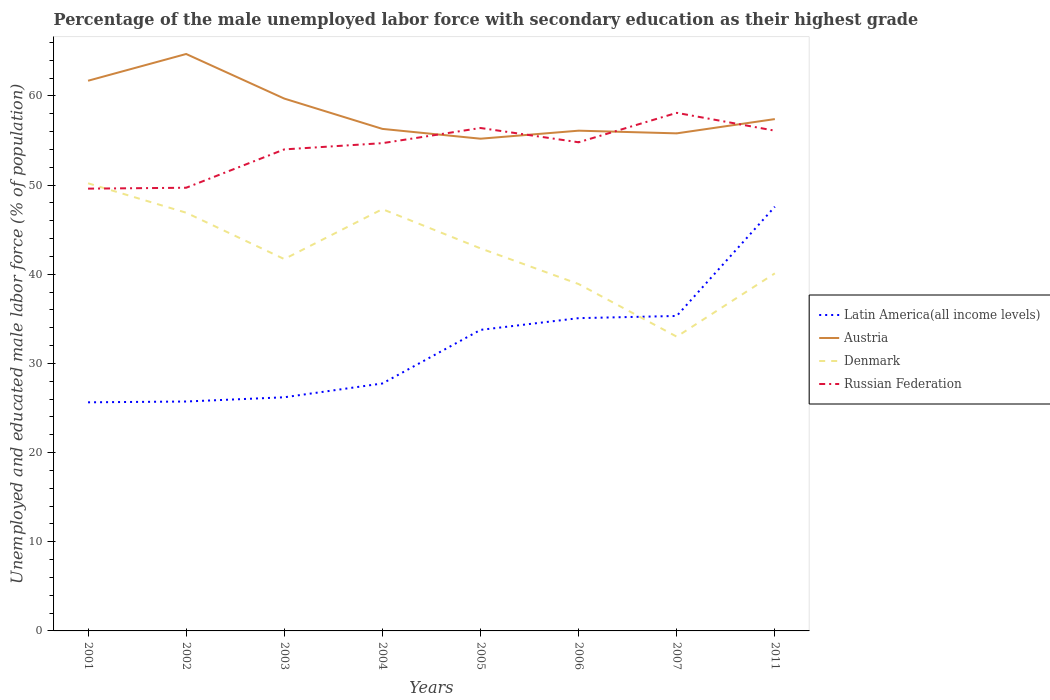How many different coloured lines are there?
Ensure brevity in your answer.  4. Does the line corresponding to Latin America(all income levels) intersect with the line corresponding to Austria?
Make the answer very short. No. What is the total percentage of the unemployed male labor force with secondary education in Denmark in the graph?
Provide a succinct answer. -1.2. What is the difference between the highest and the second highest percentage of the unemployed male labor force with secondary education in Denmark?
Your answer should be compact. 17.2. How many lines are there?
Give a very brief answer. 4. How many years are there in the graph?
Keep it short and to the point. 8. What is the difference between two consecutive major ticks on the Y-axis?
Your answer should be compact. 10. Where does the legend appear in the graph?
Provide a succinct answer. Center right. What is the title of the graph?
Your response must be concise. Percentage of the male unemployed labor force with secondary education as their highest grade. What is the label or title of the X-axis?
Make the answer very short. Years. What is the label or title of the Y-axis?
Give a very brief answer. Unemployed and educated male labor force (% of population). What is the Unemployed and educated male labor force (% of population) in Latin America(all income levels) in 2001?
Offer a terse response. 25.64. What is the Unemployed and educated male labor force (% of population) of Austria in 2001?
Offer a very short reply. 61.7. What is the Unemployed and educated male labor force (% of population) of Denmark in 2001?
Give a very brief answer. 50.2. What is the Unemployed and educated male labor force (% of population) in Russian Federation in 2001?
Keep it short and to the point. 49.6. What is the Unemployed and educated male labor force (% of population) in Latin America(all income levels) in 2002?
Offer a terse response. 25.73. What is the Unemployed and educated male labor force (% of population) in Austria in 2002?
Your answer should be very brief. 64.7. What is the Unemployed and educated male labor force (% of population) in Denmark in 2002?
Give a very brief answer. 46.9. What is the Unemployed and educated male labor force (% of population) in Russian Federation in 2002?
Your answer should be very brief. 49.7. What is the Unemployed and educated male labor force (% of population) of Latin America(all income levels) in 2003?
Make the answer very short. 26.2. What is the Unemployed and educated male labor force (% of population) of Austria in 2003?
Your answer should be very brief. 59.7. What is the Unemployed and educated male labor force (% of population) of Denmark in 2003?
Your answer should be compact. 41.7. What is the Unemployed and educated male labor force (% of population) of Russian Federation in 2003?
Ensure brevity in your answer.  54. What is the Unemployed and educated male labor force (% of population) of Latin America(all income levels) in 2004?
Offer a terse response. 27.75. What is the Unemployed and educated male labor force (% of population) in Austria in 2004?
Make the answer very short. 56.3. What is the Unemployed and educated male labor force (% of population) in Denmark in 2004?
Provide a succinct answer. 47.3. What is the Unemployed and educated male labor force (% of population) in Russian Federation in 2004?
Offer a very short reply. 54.7. What is the Unemployed and educated male labor force (% of population) in Latin America(all income levels) in 2005?
Ensure brevity in your answer.  33.76. What is the Unemployed and educated male labor force (% of population) of Austria in 2005?
Your response must be concise. 55.2. What is the Unemployed and educated male labor force (% of population) of Denmark in 2005?
Offer a very short reply. 42.9. What is the Unemployed and educated male labor force (% of population) of Russian Federation in 2005?
Your response must be concise. 56.4. What is the Unemployed and educated male labor force (% of population) in Latin America(all income levels) in 2006?
Your answer should be compact. 35.08. What is the Unemployed and educated male labor force (% of population) in Austria in 2006?
Your response must be concise. 56.1. What is the Unemployed and educated male labor force (% of population) in Denmark in 2006?
Provide a succinct answer. 38.9. What is the Unemployed and educated male labor force (% of population) in Russian Federation in 2006?
Provide a short and direct response. 54.8. What is the Unemployed and educated male labor force (% of population) in Latin America(all income levels) in 2007?
Make the answer very short. 35.32. What is the Unemployed and educated male labor force (% of population) in Austria in 2007?
Offer a terse response. 55.8. What is the Unemployed and educated male labor force (% of population) in Denmark in 2007?
Ensure brevity in your answer.  33. What is the Unemployed and educated male labor force (% of population) in Russian Federation in 2007?
Provide a succinct answer. 58.1. What is the Unemployed and educated male labor force (% of population) of Latin America(all income levels) in 2011?
Provide a succinct answer. 47.57. What is the Unemployed and educated male labor force (% of population) in Austria in 2011?
Provide a short and direct response. 57.4. What is the Unemployed and educated male labor force (% of population) in Denmark in 2011?
Provide a short and direct response. 40.1. What is the Unemployed and educated male labor force (% of population) of Russian Federation in 2011?
Offer a very short reply. 56.1. Across all years, what is the maximum Unemployed and educated male labor force (% of population) in Latin America(all income levels)?
Ensure brevity in your answer.  47.57. Across all years, what is the maximum Unemployed and educated male labor force (% of population) in Austria?
Keep it short and to the point. 64.7. Across all years, what is the maximum Unemployed and educated male labor force (% of population) of Denmark?
Your answer should be compact. 50.2. Across all years, what is the maximum Unemployed and educated male labor force (% of population) in Russian Federation?
Give a very brief answer. 58.1. Across all years, what is the minimum Unemployed and educated male labor force (% of population) of Latin America(all income levels)?
Provide a short and direct response. 25.64. Across all years, what is the minimum Unemployed and educated male labor force (% of population) of Austria?
Offer a very short reply. 55.2. Across all years, what is the minimum Unemployed and educated male labor force (% of population) in Russian Federation?
Your answer should be very brief. 49.6. What is the total Unemployed and educated male labor force (% of population) of Latin America(all income levels) in the graph?
Your response must be concise. 257.05. What is the total Unemployed and educated male labor force (% of population) in Austria in the graph?
Give a very brief answer. 466.9. What is the total Unemployed and educated male labor force (% of population) of Denmark in the graph?
Ensure brevity in your answer.  341. What is the total Unemployed and educated male labor force (% of population) of Russian Federation in the graph?
Offer a very short reply. 433.4. What is the difference between the Unemployed and educated male labor force (% of population) in Latin America(all income levels) in 2001 and that in 2002?
Ensure brevity in your answer.  -0.09. What is the difference between the Unemployed and educated male labor force (% of population) of Russian Federation in 2001 and that in 2002?
Offer a terse response. -0.1. What is the difference between the Unemployed and educated male labor force (% of population) in Latin America(all income levels) in 2001 and that in 2003?
Keep it short and to the point. -0.57. What is the difference between the Unemployed and educated male labor force (% of population) of Denmark in 2001 and that in 2003?
Your answer should be very brief. 8.5. What is the difference between the Unemployed and educated male labor force (% of population) in Russian Federation in 2001 and that in 2003?
Offer a terse response. -4.4. What is the difference between the Unemployed and educated male labor force (% of population) of Latin America(all income levels) in 2001 and that in 2004?
Your answer should be compact. -2.11. What is the difference between the Unemployed and educated male labor force (% of population) of Austria in 2001 and that in 2004?
Offer a terse response. 5.4. What is the difference between the Unemployed and educated male labor force (% of population) in Russian Federation in 2001 and that in 2004?
Ensure brevity in your answer.  -5.1. What is the difference between the Unemployed and educated male labor force (% of population) in Latin America(all income levels) in 2001 and that in 2005?
Provide a short and direct response. -8.12. What is the difference between the Unemployed and educated male labor force (% of population) in Austria in 2001 and that in 2005?
Your response must be concise. 6.5. What is the difference between the Unemployed and educated male labor force (% of population) of Latin America(all income levels) in 2001 and that in 2006?
Provide a short and direct response. -9.44. What is the difference between the Unemployed and educated male labor force (% of population) of Latin America(all income levels) in 2001 and that in 2007?
Your answer should be very brief. -9.69. What is the difference between the Unemployed and educated male labor force (% of population) of Russian Federation in 2001 and that in 2007?
Keep it short and to the point. -8.5. What is the difference between the Unemployed and educated male labor force (% of population) of Latin America(all income levels) in 2001 and that in 2011?
Keep it short and to the point. -21.94. What is the difference between the Unemployed and educated male labor force (% of population) of Austria in 2001 and that in 2011?
Give a very brief answer. 4.3. What is the difference between the Unemployed and educated male labor force (% of population) of Latin America(all income levels) in 2002 and that in 2003?
Your response must be concise. -0.48. What is the difference between the Unemployed and educated male labor force (% of population) of Denmark in 2002 and that in 2003?
Your response must be concise. 5.2. What is the difference between the Unemployed and educated male labor force (% of population) of Russian Federation in 2002 and that in 2003?
Provide a short and direct response. -4.3. What is the difference between the Unemployed and educated male labor force (% of population) in Latin America(all income levels) in 2002 and that in 2004?
Your response must be concise. -2.02. What is the difference between the Unemployed and educated male labor force (% of population) in Russian Federation in 2002 and that in 2004?
Provide a short and direct response. -5. What is the difference between the Unemployed and educated male labor force (% of population) in Latin America(all income levels) in 2002 and that in 2005?
Give a very brief answer. -8.03. What is the difference between the Unemployed and educated male labor force (% of population) of Russian Federation in 2002 and that in 2005?
Keep it short and to the point. -6.7. What is the difference between the Unemployed and educated male labor force (% of population) of Latin America(all income levels) in 2002 and that in 2006?
Offer a terse response. -9.35. What is the difference between the Unemployed and educated male labor force (% of population) of Latin America(all income levels) in 2002 and that in 2007?
Make the answer very short. -9.59. What is the difference between the Unemployed and educated male labor force (% of population) in Austria in 2002 and that in 2007?
Your response must be concise. 8.9. What is the difference between the Unemployed and educated male labor force (% of population) of Denmark in 2002 and that in 2007?
Offer a very short reply. 13.9. What is the difference between the Unemployed and educated male labor force (% of population) in Latin America(all income levels) in 2002 and that in 2011?
Provide a short and direct response. -21.85. What is the difference between the Unemployed and educated male labor force (% of population) of Austria in 2002 and that in 2011?
Provide a succinct answer. 7.3. What is the difference between the Unemployed and educated male labor force (% of population) in Denmark in 2002 and that in 2011?
Offer a terse response. 6.8. What is the difference between the Unemployed and educated male labor force (% of population) in Latin America(all income levels) in 2003 and that in 2004?
Your answer should be compact. -1.55. What is the difference between the Unemployed and educated male labor force (% of population) in Denmark in 2003 and that in 2004?
Make the answer very short. -5.6. What is the difference between the Unemployed and educated male labor force (% of population) in Russian Federation in 2003 and that in 2004?
Keep it short and to the point. -0.7. What is the difference between the Unemployed and educated male labor force (% of population) of Latin America(all income levels) in 2003 and that in 2005?
Ensure brevity in your answer.  -7.56. What is the difference between the Unemployed and educated male labor force (% of population) in Russian Federation in 2003 and that in 2005?
Make the answer very short. -2.4. What is the difference between the Unemployed and educated male labor force (% of population) in Latin America(all income levels) in 2003 and that in 2006?
Offer a terse response. -8.87. What is the difference between the Unemployed and educated male labor force (% of population) of Russian Federation in 2003 and that in 2006?
Ensure brevity in your answer.  -0.8. What is the difference between the Unemployed and educated male labor force (% of population) of Latin America(all income levels) in 2003 and that in 2007?
Provide a succinct answer. -9.12. What is the difference between the Unemployed and educated male labor force (% of population) of Denmark in 2003 and that in 2007?
Offer a terse response. 8.7. What is the difference between the Unemployed and educated male labor force (% of population) of Latin America(all income levels) in 2003 and that in 2011?
Offer a very short reply. -21.37. What is the difference between the Unemployed and educated male labor force (% of population) in Latin America(all income levels) in 2004 and that in 2005?
Your answer should be very brief. -6.01. What is the difference between the Unemployed and educated male labor force (% of population) of Austria in 2004 and that in 2005?
Give a very brief answer. 1.1. What is the difference between the Unemployed and educated male labor force (% of population) in Denmark in 2004 and that in 2005?
Your answer should be compact. 4.4. What is the difference between the Unemployed and educated male labor force (% of population) of Russian Federation in 2004 and that in 2005?
Provide a succinct answer. -1.7. What is the difference between the Unemployed and educated male labor force (% of population) in Latin America(all income levels) in 2004 and that in 2006?
Your answer should be very brief. -7.33. What is the difference between the Unemployed and educated male labor force (% of population) of Austria in 2004 and that in 2006?
Offer a very short reply. 0.2. What is the difference between the Unemployed and educated male labor force (% of population) of Russian Federation in 2004 and that in 2006?
Your answer should be compact. -0.1. What is the difference between the Unemployed and educated male labor force (% of population) in Latin America(all income levels) in 2004 and that in 2007?
Your response must be concise. -7.57. What is the difference between the Unemployed and educated male labor force (% of population) in Latin America(all income levels) in 2004 and that in 2011?
Keep it short and to the point. -19.82. What is the difference between the Unemployed and educated male labor force (% of population) in Austria in 2004 and that in 2011?
Give a very brief answer. -1.1. What is the difference between the Unemployed and educated male labor force (% of population) of Latin America(all income levels) in 2005 and that in 2006?
Ensure brevity in your answer.  -1.32. What is the difference between the Unemployed and educated male labor force (% of population) in Denmark in 2005 and that in 2006?
Provide a succinct answer. 4. What is the difference between the Unemployed and educated male labor force (% of population) of Latin America(all income levels) in 2005 and that in 2007?
Provide a short and direct response. -1.56. What is the difference between the Unemployed and educated male labor force (% of population) of Austria in 2005 and that in 2007?
Keep it short and to the point. -0.6. What is the difference between the Unemployed and educated male labor force (% of population) in Denmark in 2005 and that in 2007?
Provide a short and direct response. 9.9. What is the difference between the Unemployed and educated male labor force (% of population) in Russian Federation in 2005 and that in 2007?
Provide a succinct answer. -1.7. What is the difference between the Unemployed and educated male labor force (% of population) in Latin America(all income levels) in 2005 and that in 2011?
Provide a short and direct response. -13.81. What is the difference between the Unemployed and educated male labor force (% of population) in Denmark in 2005 and that in 2011?
Offer a very short reply. 2.8. What is the difference between the Unemployed and educated male labor force (% of population) in Russian Federation in 2005 and that in 2011?
Offer a terse response. 0.3. What is the difference between the Unemployed and educated male labor force (% of population) of Latin America(all income levels) in 2006 and that in 2007?
Provide a succinct answer. -0.25. What is the difference between the Unemployed and educated male labor force (% of population) of Austria in 2006 and that in 2007?
Your answer should be compact. 0.3. What is the difference between the Unemployed and educated male labor force (% of population) of Denmark in 2006 and that in 2007?
Your response must be concise. 5.9. What is the difference between the Unemployed and educated male labor force (% of population) of Russian Federation in 2006 and that in 2007?
Offer a very short reply. -3.3. What is the difference between the Unemployed and educated male labor force (% of population) in Latin America(all income levels) in 2006 and that in 2011?
Your answer should be compact. -12.5. What is the difference between the Unemployed and educated male labor force (% of population) of Austria in 2006 and that in 2011?
Provide a short and direct response. -1.3. What is the difference between the Unemployed and educated male labor force (% of population) in Russian Federation in 2006 and that in 2011?
Offer a terse response. -1.3. What is the difference between the Unemployed and educated male labor force (% of population) in Latin America(all income levels) in 2007 and that in 2011?
Ensure brevity in your answer.  -12.25. What is the difference between the Unemployed and educated male labor force (% of population) of Austria in 2007 and that in 2011?
Keep it short and to the point. -1.6. What is the difference between the Unemployed and educated male labor force (% of population) in Denmark in 2007 and that in 2011?
Keep it short and to the point. -7.1. What is the difference between the Unemployed and educated male labor force (% of population) of Russian Federation in 2007 and that in 2011?
Your answer should be very brief. 2. What is the difference between the Unemployed and educated male labor force (% of population) in Latin America(all income levels) in 2001 and the Unemployed and educated male labor force (% of population) in Austria in 2002?
Offer a very short reply. -39.06. What is the difference between the Unemployed and educated male labor force (% of population) in Latin America(all income levels) in 2001 and the Unemployed and educated male labor force (% of population) in Denmark in 2002?
Ensure brevity in your answer.  -21.26. What is the difference between the Unemployed and educated male labor force (% of population) of Latin America(all income levels) in 2001 and the Unemployed and educated male labor force (% of population) of Russian Federation in 2002?
Ensure brevity in your answer.  -24.06. What is the difference between the Unemployed and educated male labor force (% of population) in Austria in 2001 and the Unemployed and educated male labor force (% of population) in Denmark in 2002?
Make the answer very short. 14.8. What is the difference between the Unemployed and educated male labor force (% of population) in Latin America(all income levels) in 2001 and the Unemployed and educated male labor force (% of population) in Austria in 2003?
Your answer should be compact. -34.06. What is the difference between the Unemployed and educated male labor force (% of population) in Latin America(all income levels) in 2001 and the Unemployed and educated male labor force (% of population) in Denmark in 2003?
Offer a terse response. -16.06. What is the difference between the Unemployed and educated male labor force (% of population) of Latin America(all income levels) in 2001 and the Unemployed and educated male labor force (% of population) of Russian Federation in 2003?
Your response must be concise. -28.36. What is the difference between the Unemployed and educated male labor force (% of population) in Austria in 2001 and the Unemployed and educated male labor force (% of population) in Denmark in 2003?
Ensure brevity in your answer.  20. What is the difference between the Unemployed and educated male labor force (% of population) in Latin America(all income levels) in 2001 and the Unemployed and educated male labor force (% of population) in Austria in 2004?
Offer a very short reply. -30.66. What is the difference between the Unemployed and educated male labor force (% of population) of Latin America(all income levels) in 2001 and the Unemployed and educated male labor force (% of population) of Denmark in 2004?
Keep it short and to the point. -21.66. What is the difference between the Unemployed and educated male labor force (% of population) in Latin America(all income levels) in 2001 and the Unemployed and educated male labor force (% of population) in Russian Federation in 2004?
Make the answer very short. -29.06. What is the difference between the Unemployed and educated male labor force (% of population) of Austria in 2001 and the Unemployed and educated male labor force (% of population) of Russian Federation in 2004?
Provide a succinct answer. 7. What is the difference between the Unemployed and educated male labor force (% of population) in Denmark in 2001 and the Unemployed and educated male labor force (% of population) in Russian Federation in 2004?
Your answer should be compact. -4.5. What is the difference between the Unemployed and educated male labor force (% of population) in Latin America(all income levels) in 2001 and the Unemployed and educated male labor force (% of population) in Austria in 2005?
Offer a very short reply. -29.56. What is the difference between the Unemployed and educated male labor force (% of population) of Latin America(all income levels) in 2001 and the Unemployed and educated male labor force (% of population) of Denmark in 2005?
Make the answer very short. -17.26. What is the difference between the Unemployed and educated male labor force (% of population) of Latin America(all income levels) in 2001 and the Unemployed and educated male labor force (% of population) of Russian Federation in 2005?
Give a very brief answer. -30.76. What is the difference between the Unemployed and educated male labor force (% of population) of Austria in 2001 and the Unemployed and educated male labor force (% of population) of Denmark in 2005?
Your answer should be very brief. 18.8. What is the difference between the Unemployed and educated male labor force (% of population) in Denmark in 2001 and the Unemployed and educated male labor force (% of population) in Russian Federation in 2005?
Give a very brief answer. -6.2. What is the difference between the Unemployed and educated male labor force (% of population) in Latin America(all income levels) in 2001 and the Unemployed and educated male labor force (% of population) in Austria in 2006?
Your answer should be compact. -30.46. What is the difference between the Unemployed and educated male labor force (% of population) in Latin America(all income levels) in 2001 and the Unemployed and educated male labor force (% of population) in Denmark in 2006?
Offer a terse response. -13.26. What is the difference between the Unemployed and educated male labor force (% of population) of Latin America(all income levels) in 2001 and the Unemployed and educated male labor force (% of population) of Russian Federation in 2006?
Your answer should be very brief. -29.16. What is the difference between the Unemployed and educated male labor force (% of population) in Austria in 2001 and the Unemployed and educated male labor force (% of population) in Denmark in 2006?
Give a very brief answer. 22.8. What is the difference between the Unemployed and educated male labor force (% of population) of Austria in 2001 and the Unemployed and educated male labor force (% of population) of Russian Federation in 2006?
Offer a very short reply. 6.9. What is the difference between the Unemployed and educated male labor force (% of population) in Latin America(all income levels) in 2001 and the Unemployed and educated male labor force (% of population) in Austria in 2007?
Ensure brevity in your answer.  -30.16. What is the difference between the Unemployed and educated male labor force (% of population) in Latin America(all income levels) in 2001 and the Unemployed and educated male labor force (% of population) in Denmark in 2007?
Provide a short and direct response. -7.36. What is the difference between the Unemployed and educated male labor force (% of population) of Latin America(all income levels) in 2001 and the Unemployed and educated male labor force (% of population) of Russian Federation in 2007?
Your answer should be very brief. -32.46. What is the difference between the Unemployed and educated male labor force (% of population) in Austria in 2001 and the Unemployed and educated male labor force (% of population) in Denmark in 2007?
Your response must be concise. 28.7. What is the difference between the Unemployed and educated male labor force (% of population) in Austria in 2001 and the Unemployed and educated male labor force (% of population) in Russian Federation in 2007?
Give a very brief answer. 3.6. What is the difference between the Unemployed and educated male labor force (% of population) of Latin America(all income levels) in 2001 and the Unemployed and educated male labor force (% of population) of Austria in 2011?
Offer a terse response. -31.76. What is the difference between the Unemployed and educated male labor force (% of population) of Latin America(all income levels) in 2001 and the Unemployed and educated male labor force (% of population) of Denmark in 2011?
Your answer should be compact. -14.46. What is the difference between the Unemployed and educated male labor force (% of population) of Latin America(all income levels) in 2001 and the Unemployed and educated male labor force (% of population) of Russian Federation in 2011?
Provide a short and direct response. -30.46. What is the difference between the Unemployed and educated male labor force (% of population) in Austria in 2001 and the Unemployed and educated male labor force (% of population) in Denmark in 2011?
Provide a succinct answer. 21.6. What is the difference between the Unemployed and educated male labor force (% of population) in Latin America(all income levels) in 2002 and the Unemployed and educated male labor force (% of population) in Austria in 2003?
Keep it short and to the point. -33.97. What is the difference between the Unemployed and educated male labor force (% of population) in Latin America(all income levels) in 2002 and the Unemployed and educated male labor force (% of population) in Denmark in 2003?
Provide a succinct answer. -15.97. What is the difference between the Unemployed and educated male labor force (% of population) of Latin America(all income levels) in 2002 and the Unemployed and educated male labor force (% of population) of Russian Federation in 2003?
Provide a succinct answer. -28.27. What is the difference between the Unemployed and educated male labor force (% of population) of Austria in 2002 and the Unemployed and educated male labor force (% of population) of Denmark in 2003?
Your response must be concise. 23. What is the difference between the Unemployed and educated male labor force (% of population) of Austria in 2002 and the Unemployed and educated male labor force (% of population) of Russian Federation in 2003?
Your response must be concise. 10.7. What is the difference between the Unemployed and educated male labor force (% of population) of Denmark in 2002 and the Unemployed and educated male labor force (% of population) of Russian Federation in 2003?
Your response must be concise. -7.1. What is the difference between the Unemployed and educated male labor force (% of population) of Latin America(all income levels) in 2002 and the Unemployed and educated male labor force (% of population) of Austria in 2004?
Your answer should be very brief. -30.57. What is the difference between the Unemployed and educated male labor force (% of population) of Latin America(all income levels) in 2002 and the Unemployed and educated male labor force (% of population) of Denmark in 2004?
Keep it short and to the point. -21.57. What is the difference between the Unemployed and educated male labor force (% of population) of Latin America(all income levels) in 2002 and the Unemployed and educated male labor force (% of population) of Russian Federation in 2004?
Provide a succinct answer. -28.97. What is the difference between the Unemployed and educated male labor force (% of population) in Austria in 2002 and the Unemployed and educated male labor force (% of population) in Russian Federation in 2004?
Your answer should be compact. 10. What is the difference between the Unemployed and educated male labor force (% of population) in Denmark in 2002 and the Unemployed and educated male labor force (% of population) in Russian Federation in 2004?
Ensure brevity in your answer.  -7.8. What is the difference between the Unemployed and educated male labor force (% of population) in Latin America(all income levels) in 2002 and the Unemployed and educated male labor force (% of population) in Austria in 2005?
Provide a short and direct response. -29.47. What is the difference between the Unemployed and educated male labor force (% of population) of Latin America(all income levels) in 2002 and the Unemployed and educated male labor force (% of population) of Denmark in 2005?
Provide a succinct answer. -17.17. What is the difference between the Unemployed and educated male labor force (% of population) in Latin America(all income levels) in 2002 and the Unemployed and educated male labor force (% of population) in Russian Federation in 2005?
Offer a terse response. -30.67. What is the difference between the Unemployed and educated male labor force (% of population) of Austria in 2002 and the Unemployed and educated male labor force (% of population) of Denmark in 2005?
Offer a terse response. 21.8. What is the difference between the Unemployed and educated male labor force (% of population) of Austria in 2002 and the Unemployed and educated male labor force (% of population) of Russian Federation in 2005?
Your answer should be very brief. 8.3. What is the difference between the Unemployed and educated male labor force (% of population) in Latin America(all income levels) in 2002 and the Unemployed and educated male labor force (% of population) in Austria in 2006?
Your answer should be compact. -30.37. What is the difference between the Unemployed and educated male labor force (% of population) of Latin America(all income levels) in 2002 and the Unemployed and educated male labor force (% of population) of Denmark in 2006?
Your response must be concise. -13.17. What is the difference between the Unemployed and educated male labor force (% of population) in Latin America(all income levels) in 2002 and the Unemployed and educated male labor force (% of population) in Russian Federation in 2006?
Provide a short and direct response. -29.07. What is the difference between the Unemployed and educated male labor force (% of population) in Austria in 2002 and the Unemployed and educated male labor force (% of population) in Denmark in 2006?
Provide a succinct answer. 25.8. What is the difference between the Unemployed and educated male labor force (% of population) of Denmark in 2002 and the Unemployed and educated male labor force (% of population) of Russian Federation in 2006?
Ensure brevity in your answer.  -7.9. What is the difference between the Unemployed and educated male labor force (% of population) of Latin America(all income levels) in 2002 and the Unemployed and educated male labor force (% of population) of Austria in 2007?
Provide a short and direct response. -30.07. What is the difference between the Unemployed and educated male labor force (% of population) of Latin America(all income levels) in 2002 and the Unemployed and educated male labor force (% of population) of Denmark in 2007?
Give a very brief answer. -7.27. What is the difference between the Unemployed and educated male labor force (% of population) in Latin America(all income levels) in 2002 and the Unemployed and educated male labor force (% of population) in Russian Federation in 2007?
Offer a very short reply. -32.37. What is the difference between the Unemployed and educated male labor force (% of population) of Austria in 2002 and the Unemployed and educated male labor force (% of population) of Denmark in 2007?
Offer a very short reply. 31.7. What is the difference between the Unemployed and educated male labor force (% of population) in Denmark in 2002 and the Unemployed and educated male labor force (% of population) in Russian Federation in 2007?
Your answer should be compact. -11.2. What is the difference between the Unemployed and educated male labor force (% of population) of Latin America(all income levels) in 2002 and the Unemployed and educated male labor force (% of population) of Austria in 2011?
Make the answer very short. -31.67. What is the difference between the Unemployed and educated male labor force (% of population) of Latin America(all income levels) in 2002 and the Unemployed and educated male labor force (% of population) of Denmark in 2011?
Your response must be concise. -14.37. What is the difference between the Unemployed and educated male labor force (% of population) in Latin America(all income levels) in 2002 and the Unemployed and educated male labor force (% of population) in Russian Federation in 2011?
Provide a short and direct response. -30.37. What is the difference between the Unemployed and educated male labor force (% of population) in Austria in 2002 and the Unemployed and educated male labor force (% of population) in Denmark in 2011?
Provide a short and direct response. 24.6. What is the difference between the Unemployed and educated male labor force (% of population) of Austria in 2002 and the Unemployed and educated male labor force (% of population) of Russian Federation in 2011?
Provide a short and direct response. 8.6. What is the difference between the Unemployed and educated male labor force (% of population) in Denmark in 2002 and the Unemployed and educated male labor force (% of population) in Russian Federation in 2011?
Keep it short and to the point. -9.2. What is the difference between the Unemployed and educated male labor force (% of population) in Latin America(all income levels) in 2003 and the Unemployed and educated male labor force (% of population) in Austria in 2004?
Provide a succinct answer. -30.1. What is the difference between the Unemployed and educated male labor force (% of population) in Latin America(all income levels) in 2003 and the Unemployed and educated male labor force (% of population) in Denmark in 2004?
Provide a short and direct response. -21.1. What is the difference between the Unemployed and educated male labor force (% of population) of Latin America(all income levels) in 2003 and the Unemployed and educated male labor force (% of population) of Russian Federation in 2004?
Your answer should be compact. -28.5. What is the difference between the Unemployed and educated male labor force (% of population) in Austria in 2003 and the Unemployed and educated male labor force (% of population) in Russian Federation in 2004?
Your response must be concise. 5. What is the difference between the Unemployed and educated male labor force (% of population) in Denmark in 2003 and the Unemployed and educated male labor force (% of population) in Russian Federation in 2004?
Ensure brevity in your answer.  -13. What is the difference between the Unemployed and educated male labor force (% of population) in Latin America(all income levels) in 2003 and the Unemployed and educated male labor force (% of population) in Austria in 2005?
Offer a terse response. -29. What is the difference between the Unemployed and educated male labor force (% of population) of Latin America(all income levels) in 2003 and the Unemployed and educated male labor force (% of population) of Denmark in 2005?
Provide a succinct answer. -16.7. What is the difference between the Unemployed and educated male labor force (% of population) in Latin America(all income levels) in 2003 and the Unemployed and educated male labor force (% of population) in Russian Federation in 2005?
Ensure brevity in your answer.  -30.2. What is the difference between the Unemployed and educated male labor force (% of population) of Austria in 2003 and the Unemployed and educated male labor force (% of population) of Denmark in 2005?
Keep it short and to the point. 16.8. What is the difference between the Unemployed and educated male labor force (% of population) in Denmark in 2003 and the Unemployed and educated male labor force (% of population) in Russian Federation in 2005?
Your response must be concise. -14.7. What is the difference between the Unemployed and educated male labor force (% of population) in Latin America(all income levels) in 2003 and the Unemployed and educated male labor force (% of population) in Austria in 2006?
Make the answer very short. -29.9. What is the difference between the Unemployed and educated male labor force (% of population) in Latin America(all income levels) in 2003 and the Unemployed and educated male labor force (% of population) in Denmark in 2006?
Give a very brief answer. -12.7. What is the difference between the Unemployed and educated male labor force (% of population) of Latin America(all income levels) in 2003 and the Unemployed and educated male labor force (% of population) of Russian Federation in 2006?
Offer a very short reply. -28.6. What is the difference between the Unemployed and educated male labor force (% of population) in Austria in 2003 and the Unemployed and educated male labor force (% of population) in Denmark in 2006?
Provide a succinct answer. 20.8. What is the difference between the Unemployed and educated male labor force (% of population) in Denmark in 2003 and the Unemployed and educated male labor force (% of population) in Russian Federation in 2006?
Your response must be concise. -13.1. What is the difference between the Unemployed and educated male labor force (% of population) of Latin America(all income levels) in 2003 and the Unemployed and educated male labor force (% of population) of Austria in 2007?
Give a very brief answer. -29.6. What is the difference between the Unemployed and educated male labor force (% of population) of Latin America(all income levels) in 2003 and the Unemployed and educated male labor force (% of population) of Denmark in 2007?
Give a very brief answer. -6.8. What is the difference between the Unemployed and educated male labor force (% of population) in Latin America(all income levels) in 2003 and the Unemployed and educated male labor force (% of population) in Russian Federation in 2007?
Offer a very short reply. -31.9. What is the difference between the Unemployed and educated male labor force (% of population) of Austria in 2003 and the Unemployed and educated male labor force (% of population) of Denmark in 2007?
Offer a very short reply. 26.7. What is the difference between the Unemployed and educated male labor force (% of population) in Denmark in 2003 and the Unemployed and educated male labor force (% of population) in Russian Federation in 2007?
Your answer should be very brief. -16.4. What is the difference between the Unemployed and educated male labor force (% of population) in Latin America(all income levels) in 2003 and the Unemployed and educated male labor force (% of population) in Austria in 2011?
Provide a short and direct response. -31.2. What is the difference between the Unemployed and educated male labor force (% of population) of Latin America(all income levels) in 2003 and the Unemployed and educated male labor force (% of population) of Denmark in 2011?
Your answer should be very brief. -13.9. What is the difference between the Unemployed and educated male labor force (% of population) of Latin America(all income levels) in 2003 and the Unemployed and educated male labor force (% of population) of Russian Federation in 2011?
Your response must be concise. -29.9. What is the difference between the Unemployed and educated male labor force (% of population) of Austria in 2003 and the Unemployed and educated male labor force (% of population) of Denmark in 2011?
Your response must be concise. 19.6. What is the difference between the Unemployed and educated male labor force (% of population) of Austria in 2003 and the Unemployed and educated male labor force (% of population) of Russian Federation in 2011?
Provide a succinct answer. 3.6. What is the difference between the Unemployed and educated male labor force (% of population) of Denmark in 2003 and the Unemployed and educated male labor force (% of population) of Russian Federation in 2011?
Your answer should be very brief. -14.4. What is the difference between the Unemployed and educated male labor force (% of population) in Latin America(all income levels) in 2004 and the Unemployed and educated male labor force (% of population) in Austria in 2005?
Make the answer very short. -27.45. What is the difference between the Unemployed and educated male labor force (% of population) of Latin America(all income levels) in 2004 and the Unemployed and educated male labor force (% of population) of Denmark in 2005?
Keep it short and to the point. -15.15. What is the difference between the Unemployed and educated male labor force (% of population) in Latin America(all income levels) in 2004 and the Unemployed and educated male labor force (% of population) in Russian Federation in 2005?
Provide a short and direct response. -28.65. What is the difference between the Unemployed and educated male labor force (% of population) in Austria in 2004 and the Unemployed and educated male labor force (% of population) in Russian Federation in 2005?
Ensure brevity in your answer.  -0.1. What is the difference between the Unemployed and educated male labor force (% of population) in Latin America(all income levels) in 2004 and the Unemployed and educated male labor force (% of population) in Austria in 2006?
Offer a very short reply. -28.35. What is the difference between the Unemployed and educated male labor force (% of population) in Latin America(all income levels) in 2004 and the Unemployed and educated male labor force (% of population) in Denmark in 2006?
Ensure brevity in your answer.  -11.15. What is the difference between the Unemployed and educated male labor force (% of population) of Latin America(all income levels) in 2004 and the Unemployed and educated male labor force (% of population) of Russian Federation in 2006?
Your answer should be compact. -27.05. What is the difference between the Unemployed and educated male labor force (% of population) of Austria in 2004 and the Unemployed and educated male labor force (% of population) of Denmark in 2006?
Give a very brief answer. 17.4. What is the difference between the Unemployed and educated male labor force (% of population) in Austria in 2004 and the Unemployed and educated male labor force (% of population) in Russian Federation in 2006?
Make the answer very short. 1.5. What is the difference between the Unemployed and educated male labor force (% of population) of Latin America(all income levels) in 2004 and the Unemployed and educated male labor force (% of population) of Austria in 2007?
Your answer should be compact. -28.05. What is the difference between the Unemployed and educated male labor force (% of population) in Latin America(all income levels) in 2004 and the Unemployed and educated male labor force (% of population) in Denmark in 2007?
Your answer should be very brief. -5.25. What is the difference between the Unemployed and educated male labor force (% of population) of Latin America(all income levels) in 2004 and the Unemployed and educated male labor force (% of population) of Russian Federation in 2007?
Your response must be concise. -30.35. What is the difference between the Unemployed and educated male labor force (% of population) of Austria in 2004 and the Unemployed and educated male labor force (% of population) of Denmark in 2007?
Your answer should be very brief. 23.3. What is the difference between the Unemployed and educated male labor force (% of population) of Austria in 2004 and the Unemployed and educated male labor force (% of population) of Russian Federation in 2007?
Provide a succinct answer. -1.8. What is the difference between the Unemployed and educated male labor force (% of population) in Latin America(all income levels) in 2004 and the Unemployed and educated male labor force (% of population) in Austria in 2011?
Make the answer very short. -29.65. What is the difference between the Unemployed and educated male labor force (% of population) of Latin America(all income levels) in 2004 and the Unemployed and educated male labor force (% of population) of Denmark in 2011?
Your response must be concise. -12.35. What is the difference between the Unemployed and educated male labor force (% of population) in Latin America(all income levels) in 2004 and the Unemployed and educated male labor force (% of population) in Russian Federation in 2011?
Provide a succinct answer. -28.35. What is the difference between the Unemployed and educated male labor force (% of population) in Denmark in 2004 and the Unemployed and educated male labor force (% of population) in Russian Federation in 2011?
Your response must be concise. -8.8. What is the difference between the Unemployed and educated male labor force (% of population) of Latin America(all income levels) in 2005 and the Unemployed and educated male labor force (% of population) of Austria in 2006?
Your answer should be very brief. -22.34. What is the difference between the Unemployed and educated male labor force (% of population) in Latin America(all income levels) in 2005 and the Unemployed and educated male labor force (% of population) in Denmark in 2006?
Ensure brevity in your answer.  -5.14. What is the difference between the Unemployed and educated male labor force (% of population) of Latin America(all income levels) in 2005 and the Unemployed and educated male labor force (% of population) of Russian Federation in 2006?
Offer a terse response. -21.04. What is the difference between the Unemployed and educated male labor force (% of population) in Austria in 2005 and the Unemployed and educated male labor force (% of population) in Russian Federation in 2006?
Give a very brief answer. 0.4. What is the difference between the Unemployed and educated male labor force (% of population) in Latin America(all income levels) in 2005 and the Unemployed and educated male labor force (% of population) in Austria in 2007?
Your answer should be very brief. -22.04. What is the difference between the Unemployed and educated male labor force (% of population) in Latin America(all income levels) in 2005 and the Unemployed and educated male labor force (% of population) in Denmark in 2007?
Keep it short and to the point. 0.76. What is the difference between the Unemployed and educated male labor force (% of population) in Latin America(all income levels) in 2005 and the Unemployed and educated male labor force (% of population) in Russian Federation in 2007?
Ensure brevity in your answer.  -24.34. What is the difference between the Unemployed and educated male labor force (% of population) in Austria in 2005 and the Unemployed and educated male labor force (% of population) in Russian Federation in 2007?
Your response must be concise. -2.9. What is the difference between the Unemployed and educated male labor force (% of population) in Denmark in 2005 and the Unemployed and educated male labor force (% of population) in Russian Federation in 2007?
Your answer should be very brief. -15.2. What is the difference between the Unemployed and educated male labor force (% of population) in Latin America(all income levels) in 2005 and the Unemployed and educated male labor force (% of population) in Austria in 2011?
Your answer should be very brief. -23.64. What is the difference between the Unemployed and educated male labor force (% of population) of Latin America(all income levels) in 2005 and the Unemployed and educated male labor force (% of population) of Denmark in 2011?
Ensure brevity in your answer.  -6.34. What is the difference between the Unemployed and educated male labor force (% of population) in Latin America(all income levels) in 2005 and the Unemployed and educated male labor force (% of population) in Russian Federation in 2011?
Offer a very short reply. -22.34. What is the difference between the Unemployed and educated male labor force (% of population) in Austria in 2005 and the Unemployed and educated male labor force (% of population) in Russian Federation in 2011?
Keep it short and to the point. -0.9. What is the difference between the Unemployed and educated male labor force (% of population) of Latin America(all income levels) in 2006 and the Unemployed and educated male labor force (% of population) of Austria in 2007?
Keep it short and to the point. -20.72. What is the difference between the Unemployed and educated male labor force (% of population) in Latin America(all income levels) in 2006 and the Unemployed and educated male labor force (% of population) in Denmark in 2007?
Offer a very short reply. 2.08. What is the difference between the Unemployed and educated male labor force (% of population) of Latin America(all income levels) in 2006 and the Unemployed and educated male labor force (% of population) of Russian Federation in 2007?
Offer a very short reply. -23.02. What is the difference between the Unemployed and educated male labor force (% of population) in Austria in 2006 and the Unemployed and educated male labor force (% of population) in Denmark in 2007?
Ensure brevity in your answer.  23.1. What is the difference between the Unemployed and educated male labor force (% of population) of Austria in 2006 and the Unemployed and educated male labor force (% of population) of Russian Federation in 2007?
Offer a very short reply. -2. What is the difference between the Unemployed and educated male labor force (% of population) in Denmark in 2006 and the Unemployed and educated male labor force (% of population) in Russian Federation in 2007?
Provide a succinct answer. -19.2. What is the difference between the Unemployed and educated male labor force (% of population) of Latin America(all income levels) in 2006 and the Unemployed and educated male labor force (% of population) of Austria in 2011?
Keep it short and to the point. -22.32. What is the difference between the Unemployed and educated male labor force (% of population) in Latin America(all income levels) in 2006 and the Unemployed and educated male labor force (% of population) in Denmark in 2011?
Your answer should be very brief. -5.02. What is the difference between the Unemployed and educated male labor force (% of population) of Latin America(all income levels) in 2006 and the Unemployed and educated male labor force (% of population) of Russian Federation in 2011?
Keep it short and to the point. -21.02. What is the difference between the Unemployed and educated male labor force (% of population) in Austria in 2006 and the Unemployed and educated male labor force (% of population) in Russian Federation in 2011?
Keep it short and to the point. 0. What is the difference between the Unemployed and educated male labor force (% of population) in Denmark in 2006 and the Unemployed and educated male labor force (% of population) in Russian Federation in 2011?
Make the answer very short. -17.2. What is the difference between the Unemployed and educated male labor force (% of population) in Latin America(all income levels) in 2007 and the Unemployed and educated male labor force (% of population) in Austria in 2011?
Make the answer very short. -22.08. What is the difference between the Unemployed and educated male labor force (% of population) of Latin America(all income levels) in 2007 and the Unemployed and educated male labor force (% of population) of Denmark in 2011?
Provide a succinct answer. -4.78. What is the difference between the Unemployed and educated male labor force (% of population) in Latin America(all income levels) in 2007 and the Unemployed and educated male labor force (% of population) in Russian Federation in 2011?
Your response must be concise. -20.78. What is the difference between the Unemployed and educated male labor force (% of population) in Austria in 2007 and the Unemployed and educated male labor force (% of population) in Denmark in 2011?
Ensure brevity in your answer.  15.7. What is the difference between the Unemployed and educated male labor force (% of population) of Denmark in 2007 and the Unemployed and educated male labor force (% of population) of Russian Federation in 2011?
Your answer should be very brief. -23.1. What is the average Unemployed and educated male labor force (% of population) of Latin America(all income levels) per year?
Provide a succinct answer. 32.13. What is the average Unemployed and educated male labor force (% of population) in Austria per year?
Make the answer very short. 58.36. What is the average Unemployed and educated male labor force (% of population) in Denmark per year?
Ensure brevity in your answer.  42.62. What is the average Unemployed and educated male labor force (% of population) in Russian Federation per year?
Make the answer very short. 54.17. In the year 2001, what is the difference between the Unemployed and educated male labor force (% of population) of Latin America(all income levels) and Unemployed and educated male labor force (% of population) of Austria?
Provide a succinct answer. -36.06. In the year 2001, what is the difference between the Unemployed and educated male labor force (% of population) of Latin America(all income levels) and Unemployed and educated male labor force (% of population) of Denmark?
Your response must be concise. -24.56. In the year 2001, what is the difference between the Unemployed and educated male labor force (% of population) of Latin America(all income levels) and Unemployed and educated male labor force (% of population) of Russian Federation?
Offer a terse response. -23.96. In the year 2001, what is the difference between the Unemployed and educated male labor force (% of population) in Austria and Unemployed and educated male labor force (% of population) in Denmark?
Offer a very short reply. 11.5. In the year 2001, what is the difference between the Unemployed and educated male labor force (% of population) in Austria and Unemployed and educated male labor force (% of population) in Russian Federation?
Make the answer very short. 12.1. In the year 2001, what is the difference between the Unemployed and educated male labor force (% of population) of Denmark and Unemployed and educated male labor force (% of population) of Russian Federation?
Keep it short and to the point. 0.6. In the year 2002, what is the difference between the Unemployed and educated male labor force (% of population) in Latin America(all income levels) and Unemployed and educated male labor force (% of population) in Austria?
Give a very brief answer. -38.97. In the year 2002, what is the difference between the Unemployed and educated male labor force (% of population) of Latin America(all income levels) and Unemployed and educated male labor force (% of population) of Denmark?
Your response must be concise. -21.17. In the year 2002, what is the difference between the Unemployed and educated male labor force (% of population) in Latin America(all income levels) and Unemployed and educated male labor force (% of population) in Russian Federation?
Make the answer very short. -23.97. In the year 2003, what is the difference between the Unemployed and educated male labor force (% of population) in Latin America(all income levels) and Unemployed and educated male labor force (% of population) in Austria?
Give a very brief answer. -33.5. In the year 2003, what is the difference between the Unemployed and educated male labor force (% of population) in Latin America(all income levels) and Unemployed and educated male labor force (% of population) in Denmark?
Your answer should be compact. -15.5. In the year 2003, what is the difference between the Unemployed and educated male labor force (% of population) in Latin America(all income levels) and Unemployed and educated male labor force (% of population) in Russian Federation?
Your answer should be compact. -27.8. In the year 2003, what is the difference between the Unemployed and educated male labor force (% of population) in Austria and Unemployed and educated male labor force (% of population) in Denmark?
Keep it short and to the point. 18. In the year 2003, what is the difference between the Unemployed and educated male labor force (% of population) in Austria and Unemployed and educated male labor force (% of population) in Russian Federation?
Ensure brevity in your answer.  5.7. In the year 2004, what is the difference between the Unemployed and educated male labor force (% of population) in Latin America(all income levels) and Unemployed and educated male labor force (% of population) in Austria?
Offer a terse response. -28.55. In the year 2004, what is the difference between the Unemployed and educated male labor force (% of population) in Latin America(all income levels) and Unemployed and educated male labor force (% of population) in Denmark?
Your response must be concise. -19.55. In the year 2004, what is the difference between the Unemployed and educated male labor force (% of population) in Latin America(all income levels) and Unemployed and educated male labor force (% of population) in Russian Federation?
Provide a succinct answer. -26.95. In the year 2004, what is the difference between the Unemployed and educated male labor force (% of population) of Austria and Unemployed and educated male labor force (% of population) of Denmark?
Make the answer very short. 9. In the year 2005, what is the difference between the Unemployed and educated male labor force (% of population) in Latin America(all income levels) and Unemployed and educated male labor force (% of population) in Austria?
Make the answer very short. -21.44. In the year 2005, what is the difference between the Unemployed and educated male labor force (% of population) of Latin America(all income levels) and Unemployed and educated male labor force (% of population) of Denmark?
Make the answer very short. -9.14. In the year 2005, what is the difference between the Unemployed and educated male labor force (% of population) in Latin America(all income levels) and Unemployed and educated male labor force (% of population) in Russian Federation?
Your answer should be very brief. -22.64. In the year 2005, what is the difference between the Unemployed and educated male labor force (% of population) in Austria and Unemployed and educated male labor force (% of population) in Denmark?
Your response must be concise. 12.3. In the year 2006, what is the difference between the Unemployed and educated male labor force (% of population) in Latin America(all income levels) and Unemployed and educated male labor force (% of population) in Austria?
Ensure brevity in your answer.  -21.02. In the year 2006, what is the difference between the Unemployed and educated male labor force (% of population) of Latin America(all income levels) and Unemployed and educated male labor force (% of population) of Denmark?
Give a very brief answer. -3.82. In the year 2006, what is the difference between the Unemployed and educated male labor force (% of population) of Latin America(all income levels) and Unemployed and educated male labor force (% of population) of Russian Federation?
Ensure brevity in your answer.  -19.72. In the year 2006, what is the difference between the Unemployed and educated male labor force (% of population) in Austria and Unemployed and educated male labor force (% of population) in Denmark?
Make the answer very short. 17.2. In the year 2006, what is the difference between the Unemployed and educated male labor force (% of population) of Austria and Unemployed and educated male labor force (% of population) of Russian Federation?
Make the answer very short. 1.3. In the year 2006, what is the difference between the Unemployed and educated male labor force (% of population) of Denmark and Unemployed and educated male labor force (% of population) of Russian Federation?
Make the answer very short. -15.9. In the year 2007, what is the difference between the Unemployed and educated male labor force (% of population) of Latin America(all income levels) and Unemployed and educated male labor force (% of population) of Austria?
Your answer should be compact. -20.48. In the year 2007, what is the difference between the Unemployed and educated male labor force (% of population) in Latin America(all income levels) and Unemployed and educated male labor force (% of population) in Denmark?
Your answer should be very brief. 2.32. In the year 2007, what is the difference between the Unemployed and educated male labor force (% of population) in Latin America(all income levels) and Unemployed and educated male labor force (% of population) in Russian Federation?
Provide a succinct answer. -22.78. In the year 2007, what is the difference between the Unemployed and educated male labor force (% of population) in Austria and Unemployed and educated male labor force (% of population) in Denmark?
Your response must be concise. 22.8. In the year 2007, what is the difference between the Unemployed and educated male labor force (% of population) of Austria and Unemployed and educated male labor force (% of population) of Russian Federation?
Make the answer very short. -2.3. In the year 2007, what is the difference between the Unemployed and educated male labor force (% of population) in Denmark and Unemployed and educated male labor force (% of population) in Russian Federation?
Give a very brief answer. -25.1. In the year 2011, what is the difference between the Unemployed and educated male labor force (% of population) in Latin America(all income levels) and Unemployed and educated male labor force (% of population) in Austria?
Give a very brief answer. -9.83. In the year 2011, what is the difference between the Unemployed and educated male labor force (% of population) in Latin America(all income levels) and Unemployed and educated male labor force (% of population) in Denmark?
Offer a very short reply. 7.47. In the year 2011, what is the difference between the Unemployed and educated male labor force (% of population) of Latin America(all income levels) and Unemployed and educated male labor force (% of population) of Russian Federation?
Offer a very short reply. -8.53. In the year 2011, what is the difference between the Unemployed and educated male labor force (% of population) of Denmark and Unemployed and educated male labor force (% of population) of Russian Federation?
Provide a succinct answer. -16. What is the ratio of the Unemployed and educated male labor force (% of population) in Latin America(all income levels) in 2001 to that in 2002?
Keep it short and to the point. 1. What is the ratio of the Unemployed and educated male labor force (% of population) of Austria in 2001 to that in 2002?
Give a very brief answer. 0.95. What is the ratio of the Unemployed and educated male labor force (% of population) in Denmark in 2001 to that in 2002?
Your answer should be very brief. 1.07. What is the ratio of the Unemployed and educated male labor force (% of population) of Latin America(all income levels) in 2001 to that in 2003?
Your answer should be compact. 0.98. What is the ratio of the Unemployed and educated male labor force (% of population) of Austria in 2001 to that in 2003?
Keep it short and to the point. 1.03. What is the ratio of the Unemployed and educated male labor force (% of population) of Denmark in 2001 to that in 2003?
Your answer should be very brief. 1.2. What is the ratio of the Unemployed and educated male labor force (% of population) of Russian Federation in 2001 to that in 2003?
Offer a very short reply. 0.92. What is the ratio of the Unemployed and educated male labor force (% of population) of Latin America(all income levels) in 2001 to that in 2004?
Your response must be concise. 0.92. What is the ratio of the Unemployed and educated male labor force (% of population) of Austria in 2001 to that in 2004?
Your answer should be very brief. 1.1. What is the ratio of the Unemployed and educated male labor force (% of population) of Denmark in 2001 to that in 2004?
Your response must be concise. 1.06. What is the ratio of the Unemployed and educated male labor force (% of population) of Russian Federation in 2001 to that in 2004?
Your answer should be very brief. 0.91. What is the ratio of the Unemployed and educated male labor force (% of population) in Latin America(all income levels) in 2001 to that in 2005?
Provide a succinct answer. 0.76. What is the ratio of the Unemployed and educated male labor force (% of population) of Austria in 2001 to that in 2005?
Make the answer very short. 1.12. What is the ratio of the Unemployed and educated male labor force (% of population) of Denmark in 2001 to that in 2005?
Provide a succinct answer. 1.17. What is the ratio of the Unemployed and educated male labor force (% of population) in Russian Federation in 2001 to that in 2005?
Keep it short and to the point. 0.88. What is the ratio of the Unemployed and educated male labor force (% of population) of Latin America(all income levels) in 2001 to that in 2006?
Your answer should be compact. 0.73. What is the ratio of the Unemployed and educated male labor force (% of population) in Austria in 2001 to that in 2006?
Give a very brief answer. 1.1. What is the ratio of the Unemployed and educated male labor force (% of population) in Denmark in 2001 to that in 2006?
Offer a terse response. 1.29. What is the ratio of the Unemployed and educated male labor force (% of population) of Russian Federation in 2001 to that in 2006?
Keep it short and to the point. 0.91. What is the ratio of the Unemployed and educated male labor force (% of population) in Latin America(all income levels) in 2001 to that in 2007?
Offer a very short reply. 0.73. What is the ratio of the Unemployed and educated male labor force (% of population) in Austria in 2001 to that in 2007?
Keep it short and to the point. 1.11. What is the ratio of the Unemployed and educated male labor force (% of population) of Denmark in 2001 to that in 2007?
Make the answer very short. 1.52. What is the ratio of the Unemployed and educated male labor force (% of population) in Russian Federation in 2001 to that in 2007?
Your response must be concise. 0.85. What is the ratio of the Unemployed and educated male labor force (% of population) in Latin America(all income levels) in 2001 to that in 2011?
Your answer should be very brief. 0.54. What is the ratio of the Unemployed and educated male labor force (% of population) of Austria in 2001 to that in 2011?
Your answer should be compact. 1.07. What is the ratio of the Unemployed and educated male labor force (% of population) of Denmark in 2001 to that in 2011?
Provide a succinct answer. 1.25. What is the ratio of the Unemployed and educated male labor force (% of population) of Russian Federation in 2001 to that in 2011?
Your answer should be compact. 0.88. What is the ratio of the Unemployed and educated male labor force (% of population) in Latin America(all income levels) in 2002 to that in 2003?
Your answer should be compact. 0.98. What is the ratio of the Unemployed and educated male labor force (% of population) in Austria in 2002 to that in 2003?
Keep it short and to the point. 1.08. What is the ratio of the Unemployed and educated male labor force (% of population) in Denmark in 2002 to that in 2003?
Provide a succinct answer. 1.12. What is the ratio of the Unemployed and educated male labor force (% of population) of Russian Federation in 2002 to that in 2003?
Make the answer very short. 0.92. What is the ratio of the Unemployed and educated male labor force (% of population) of Latin America(all income levels) in 2002 to that in 2004?
Offer a terse response. 0.93. What is the ratio of the Unemployed and educated male labor force (% of population) in Austria in 2002 to that in 2004?
Your answer should be compact. 1.15. What is the ratio of the Unemployed and educated male labor force (% of population) of Russian Federation in 2002 to that in 2004?
Make the answer very short. 0.91. What is the ratio of the Unemployed and educated male labor force (% of population) in Latin America(all income levels) in 2002 to that in 2005?
Offer a terse response. 0.76. What is the ratio of the Unemployed and educated male labor force (% of population) of Austria in 2002 to that in 2005?
Give a very brief answer. 1.17. What is the ratio of the Unemployed and educated male labor force (% of population) in Denmark in 2002 to that in 2005?
Keep it short and to the point. 1.09. What is the ratio of the Unemployed and educated male labor force (% of population) of Russian Federation in 2002 to that in 2005?
Your response must be concise. 0.88. What is the ratio of the Unemployed and educated male labor force (% of population) of Latin America(all income levels) in 2002 to that in 2006?
Keep it short and to the point. 0.73. What is the ratio of the Unemployed and educated male labor force (% of population) of Austria in 2002 to that in 2006?
Provide a succinct answer. 1.15. What is the ratio of the Unemployed and educated male labor force (% of population) of Denmark in 2002 to that in 2006?
Provide a succinct answer. 1.21. What is the ratio of the Unemployed and educated male labor force (% of population) of Russian Federation in 2002 to that in 2006?
Ensure brevity in your answer.  0.91. What is the ratio of the Unemployed and educated male labor force (% of population) of Latin America(all income levels) in 2002 to that in 2007?
Make the answer very short. 0.73. What is the ratio of the Unemployed and educated male labor force (% of population) in Austria in 2002 to that in 2007?
Ensure brevity in your answer.  1.16. What is the ratio of the Unemployed and educated male labor force (% of population) of Denmark in 2002 to that in 2007?
Keep it short and to the point. 1.42. What is the ratio of the Unemployed and educated male labor force (% of population) of Russian Federation in 2002 to that in 2007?
Offer a very short reply. 0.86. What is the ratio of the Unemployed and educated male labor force (% of population) in Latin America(all income levels) in 2002 to that in 2011?
Provide a short and direct response. 0.54. What is the ratio of the Unemployed and educated male labor force (% of population) in Austria in 2002 to that in 2011?
Your answer should be very brief. 1.13. What is the ratio of the Unemployed and educated male labor force (% of population) of Denmark in 2002 to that in 2011?
Make the answer very short. 1.17. What is the ratio of the Unemployed and educated male labor force (% of population) in Russian Federation in 2002 to that in 2011?
Offer a terse response. 0.89. What is the ratio of the Unemployed and educated male labor force (% of population) in Latin America(all income levels) in 2003 to that in 2004?
Keep it short and to the point. 0.94. What is the ratio of the Unemployed and educated male labor force (% of population) of Austria in 2003 to that in 2004?
Keep it short and to the point. 1.06. What is the ratio of the Unemployed and educated male labor force (% of population) in Denmark in 2003 to that in 2004?
Keep it short and to the point. 0.88. What is the ratio of the Unemployed and educated male labor force (% of population) in Russian Federation in 2003 to that in 2004?
Your answer should be very brief. 0.99. What is the ratio of the Unemployed and educated male labor force (% of population) of Latin America(all income levels) in 2003 to that in 2005?
Offer a very short reply. 0.78. What is the ratio of the Unemployed and educated male labor force (% of population) of Austria in 2003 to that in 2005?
Make the answer very short. 1.08. What is the ratio of the Unemployed and educated male labor force (% of population) in Denmark in 2003 to that in 2005?
Make the answer very short. 0.97. What is the ratio of the Unemployed and educated male labor force (% of population) in Russian Federation in 2003 to that in 2005?
Offer a terse response. 0.96. What is the ratio of the Unemployed and educated male labor force (% of population) of Latin America(all income levels) in 2003 to that in 2006?
Ensure brevity in your answer.  0.75. What is the ratio of the Unemployed and educated male labor force (% of population) in Austria in 2003 to that in 2006?
Your answer should be compact. 1.06. What is the ratio of the Unemployed and educated male labor force (% of population) in Denmark in 2003 to that in 2006?
Give a very brief answer. 1.07. What is the ratio of the Unemployed and educated male labor force (% of population) in Russian Federation in 2003 to that in 2006?
Ensure brevity in your answer.  0.99. What is the ratio of the Unemployed and educated male labor force (% of population) of Latin America(all income levels) in 2003 to that in 2007?
Keep it short and to the point. 0.74. What is the ratio of the Unemployed and educated male labor force (% of population) of Austria in 2003 to that in 2007?
Ensure brevity in your answer.  1.07. What is the ratio of the Unemployed and educated male labor force (% of population) of Denmark in 2003 to that in 2007?
Provide a succinct answer. 1.26. What is the ratio of the Unemployed and educated male labor force (% of population) of Russian Federation in 2003 to that in 2007?
Offer a terse response. 0.93. What is the ratio of the Unemployed and educated male labor force (% of population) of Latin America(all income levels) in 2003 to that in 2011?
Your answer should be compact. 0.55. What is the ratio of the Unemployed and educated male labor force (% of population) of Austria in 2003 to that in 2011?
Offer a very short reply. 1.04. What is the ratio of the Unemployed and educated male labor force (% of population) of Denmark in 2003 to that in 2011?
Provide a succinct answer. 1.04. What is the ratio of the Unemployed and educated male labor force (% of population) in Russian Federation in 2003 to that in 2011?
Offer a terse response. 0.96. What is the ratio of the Unemployed and educated male labor force (% of population) in Latin America(all income levels) in 2004 to that in 2005?
Keep it short and to the point. 0.82. What is the ratio of the Unemployed and educated male labor force (% of population) of Austria in 2004 to that in 2005?
Offer a terse response. 1.02. What is the ratio of the Unemployed and educated male labor force (% of population) in Denmark in 2004 to that in 2005?
Provide a short and direct response. 1.1. What is the ratio of the Unemployed and educated male labor force (% of population) in Russian Federation in 2004 to that in 2005?
Make the answer very short. 0.97. What is the ratio of the Unemployed and educated male labor force (% of population) of Latin America(all income levels) in 2004 to that in 2006?
Give a very brief answer. 0.79. What is the ratio of the Unemployed and educated male labor force (% of population) of Denmark in 2004 to that in 2006?
Your answer should be very brief. 1.22. What is the ratio of the Unemployed and educated male labor force (% of population) of Russian Federation in 2004 to that in 2006?
Your response must be concise. 1. What is the ratio of the Unemployed and educated male labor force (% of population) in Latin America(all income levels) in 2004 to that in 2007?
Your answer should be very brief. 0.79. What is the ratio of the Unemployed and educated male labor force (% of population) in Denmark in 2004 to that in 2007?
Your answer should be very brief. 1.43. What is the ratio of the Unemployed and educated male labor force (% of population) in Russian Federation in 2004 to that in 2007?
Offer a terse response. 0.94. What is the ratio of the Unemployed and educated male labor force (% of population) in Latin America(all income levels) in 2004 to that in 2011?
Offer a terse response. 0.58. What is the ratio of the Unemployed and educated male labor force (% of population) in Austria in 2004 to that in 2011?
Offer a very short reply. 0.98. What is the ratio of the Unemployed and educated male labor force (% of population) of Denmark in 2004 to that in 2011?
Keep it short and to the point. 1.18. What is the ratio of the Unemployed and educated male labor force (% of population) of Russian Federation in 2004 to that in 2011?
Provide a short and direct response. 0.97. What is the ratio of the Unemployed and educated male labor force (% of population) of Latin America(all income levels) in 2005 to that in 2006?
Provide a succinct answer. 0.96. What is the ratio of the Unemployed and educated male labor force (% of population) in Austria in 2005 to that in 2006?
Make the answer very short. 0.98. What is the ratio of the Unemployed and educated male labor force (% of population) in Denmark in 2005 to that in 2006?
Provide a short and direct response. 1.1. What is the ratio of the Unemployed and educated male labor force (% of population) of Russian Federation in 2005 to that in 2006?
Your response must be concise. 1.03. What is the ratio of the Unemployed and educated male labor force (% of population) of Latin America(all income levels) in 2005 to that in 2007?
Your response must be concise. 0.96. What is the ratio of the Unemployed and educated male labor force (% of population) in Austria in 2005 to that in 2007?
Your response must be concise. 0.99. What is the ratio of the Unemployed and educated male labor force (% of population) in Russian Federation in 2005 to that in 2007?
Keep it short and to the point. 0.97. What is the ratio of the Unemployed and educated male labor force (% of population) in Latin America(all income levels) in 2005 to that in 2011?
Keep it short and to the point. 0.71. What is the ratio of the Unemployed and educated male labor force (% of population) of Austria in 2005 to that in 2011?
Make the answer very short. 0.96. What is the ratio of the Unemployed and educated male labor force (% of population) in Denmark in 2005 to that in 2011?
Offer a terse response. 1.07. What is the ratio of the Unemployed and educated male labor force (% of population) in Russian Federation in 2005 to that in 2011?
Make the answer very short. 1.01. What is the ratio of the Unemployed and educated male labor force (% of population) of Austria in 2006 to that in 2007?
Make the answer very short. 1.01. What is the ratio of the Unemployed and educated male labor force (% of population) of Denmark in 2006 to that in 2007?
Your answer should be compact. 1.18. What is the ratio of the Unemployed and educated male labor force (% of population) in Russian Federation in 2006 to that in 2007?
Offer a terse response. 0.94. What is the ratio of the Unemployed and educated male labor force (% of population) in Latin America(all income levels) in 2006 to that in 2011?
Make the answer very short. 0.74. What is the ratio of the Unemployed and educated male labor force (% of population) in Austria in 2006 to that in 2011?
Provide a succinct answer. 0.98. What is the ratio of the Unemployed and educated male labor force (% of population) of Denmark in 2006 to that in 2011?
Provide a succinct answer. 0.97. What is the ratio of the Unemployed and educated male labor force (% of population) of Russian Federation in 2006 to that in 2011?
Provide a succinct answer. 0.98. What is the ratio of the Unemployed and educated male labor force (% of population) in Latin America(all income levels) in 2007 to that in 2011?
Keep it short and to the point. 0.74. What is the ratio of the Unemployed and educated male labor force (% of population) of Austria in 2007 to that in 2011?
Offer a very short reply. 0.97. What is the ratio of the Unemployed and educated male labor force (% of population) of Denmark in 2007 to that in 2011?
Your answer should be compact. 0.82. What is the ratio of the Unemployed and educated male labor force (% of population) of Russian Federation in 2007 to that in 2011?
Provide a succinct answer. 1.04. What is the difference between the highest and the second highest Unemployed and educated male labor force (% of population) of Latin America(all income levels)?
Your answer should be very brief. 12.25. What is the difference between the highest and the second highest Unemployed and educated male labor force (% of population) of Denmark?
Provide a succinct answer. 2.9. What is the difference between the highest and the second highest Unemployed and educated male labor force (% of population) of Russian Federation?
Give a very brief answer. 1.7. What is the difference between the highest and the lowest Unemployed and educated male labor force (% of population) in Latin America(all income levels)?
Ensure brevity in your answer.  21.94. What is the difference between the highest and the lowest Unemployed and educated male labor force (% of population) of Denmark?
Keep it short and to the point. 17.2. 